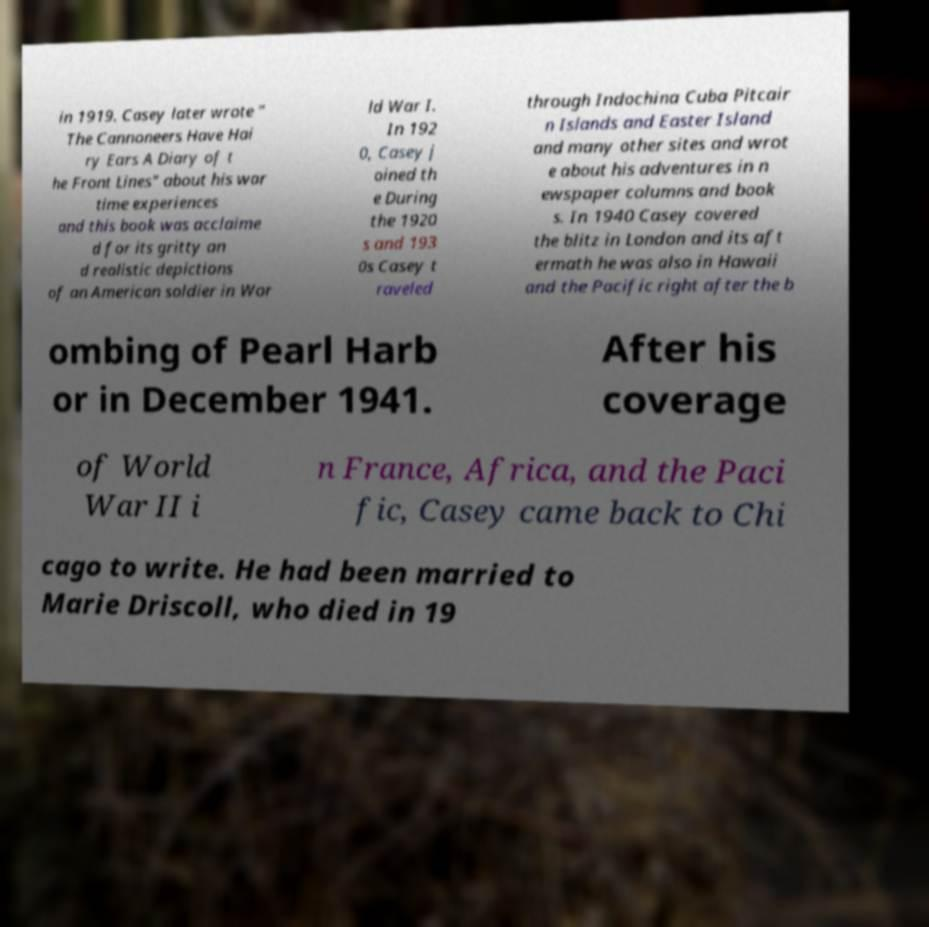Please read and relay the text visible in this image. What does it say? in 1919. Casey later wrote " The Cannoneers Have Hai ry Ears A Diary of t he Front Lines" about his war time experiences and this book was acclaime d for its gritty an d realistic depictions of an American soldier in Wor ld War I. In 192 0, Casey j oined th e During the 1920 s and 193 0s Casey t raveled through Indochina Cuba Pitcair n Islands and Easter Island and many other sites and wrot e about his adventures in n ewspaper columns and book s. In 1940 Casey covered the blitz in London and its aft ermath he was also in Hawaii and the Pacific right after the b ombing of Pearl Harb or in December 1941. After his coverage of World War II i n France, Africa, and the Paci fic, Casey came back to Chi cago to write. He had been married to Marie Driscoll, who died in 19 